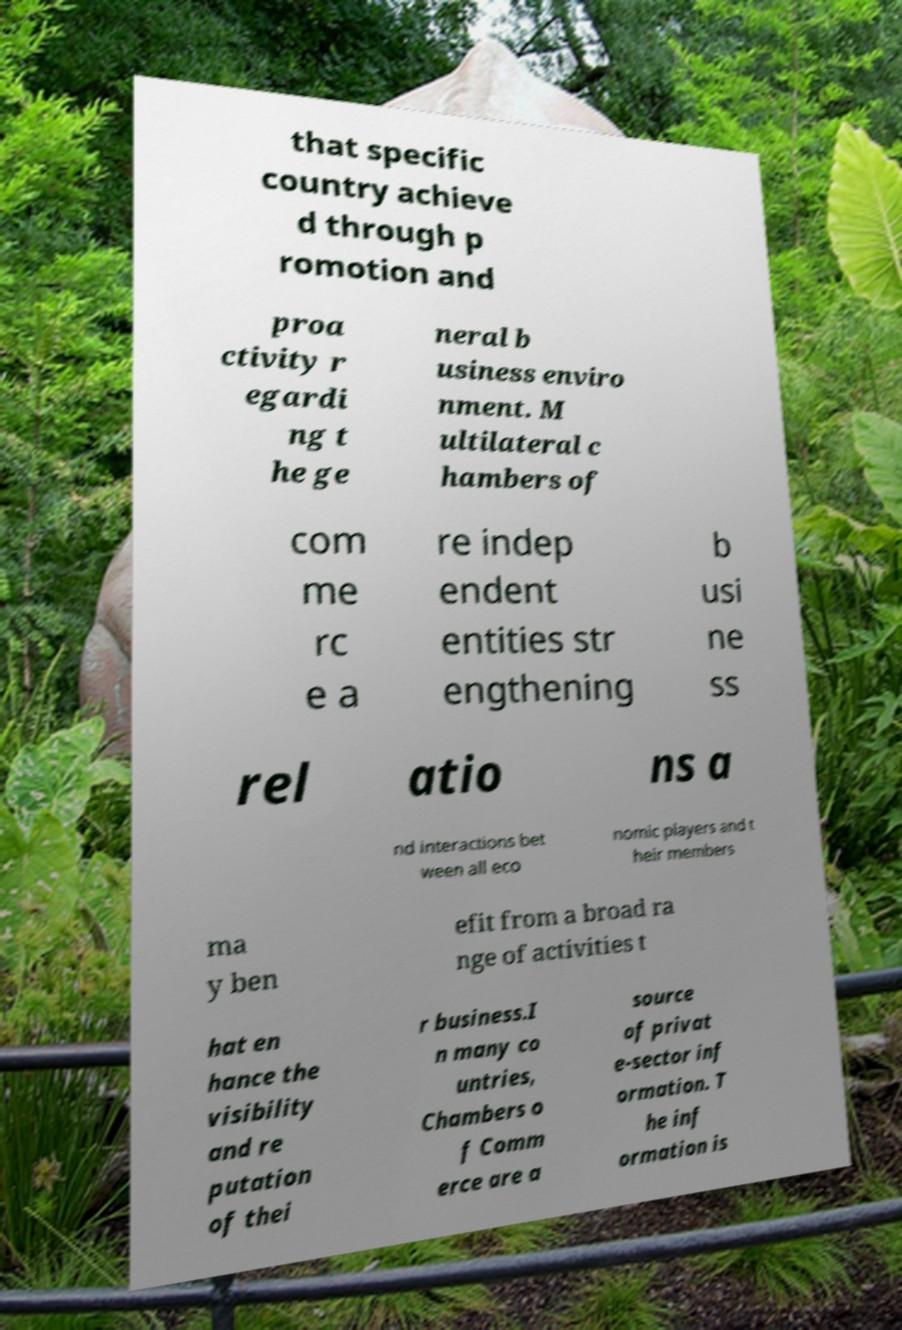Please read and relay the text visible in this image. What does it say? that specific country achieve d through p romotion and proa ctivity r egardi ng t he ge neral b usiness enviro nment. M ultilateral c hambers of com me rc e a re indep endent entities str engthening b usi ne ss rel atio ns a nd interactions bet ween all eco nomic players and t heir members ma y ben efit from a broad ra nge of activities t hat en hance the visibility and re putation of thei r business.I n many co untries, Chambers o f Comm erce are a source of privat e-sector inf ormation. T he inf ormation is 